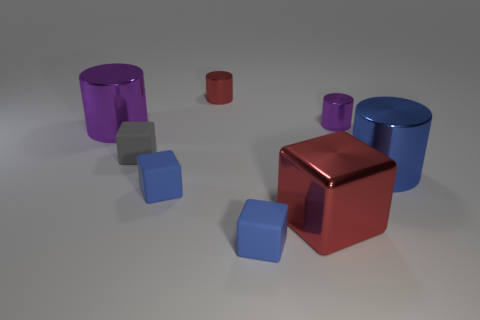Subtract all purple cylinders. How many were subtracted if there are1purple cylinders left? 1 Subtract all small gray blocks. How many blocks are left? 3 Subtract all gray blocks. How many blocks are left? 3 Subtract all gray balls. How many red blocks are left? 1 Add 2 big blue shiny cylinders. How many objects exist? 10 Subtract all small yellow metallic balls. Subtract all purple metallic objects. How many objects are left? 6 Add 5 metallic blocks. How many metallic blocks are left? 6 Add 1 brown matte cylinders. How many brown matte cylinders exist? 1 Subtract 0 brown spheres. How many objects are left? 8 Subtract 2 cubes. How many cubes are left? 2 